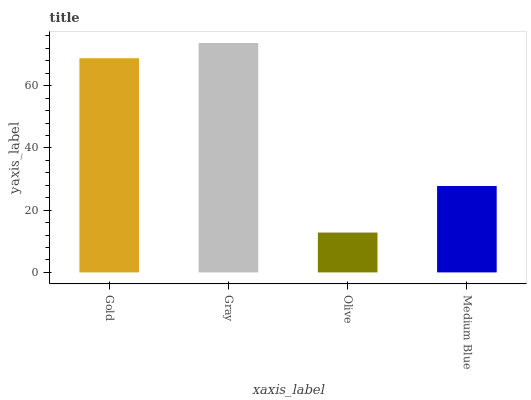Is Olive the minimum?
Answer yes or no. Yes. Is Gray the maximum?
Answer yes or no. Yes. Is Gray the minimum?
Answer yes or no. No. Is Olive the maximum?
Answer yes or no. No. Is Gray greater than Olive?
Answer yes or no. Yes. Is Olive less than Gray?
Answer yes or no. Yes. Is Olive greater than Gray?
Answer yes or no. No. Is Gray less than Olive?
Answer yes or no. No. Is Gold the high median?
Answer yes or no. Yes. Is Medium Blue the low median?
Answer yes or no. Yes. Is Olive the high median?
Answer yes or no. No. Is Gold the low median?
Answer yes or no. No. 